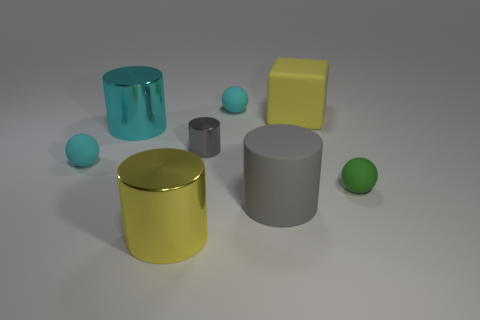Subtract all green blocks. Subtract all blue spheres. How many blocks are left? 1 Add 1 large shiny things. How many objects exist? 9 Subtract all spheres. How many objects are left? 5 Add 7 cyan spheres. How many cyan spheres are left? 9 Add 2 cyan objects. How many cyan objects exist? 5 Subtract 0 cyan cubes. How many objects are left? 8 Subtract all small green rubber objects. Subtract all cyan rubber spheres. How many objects are left? 5 